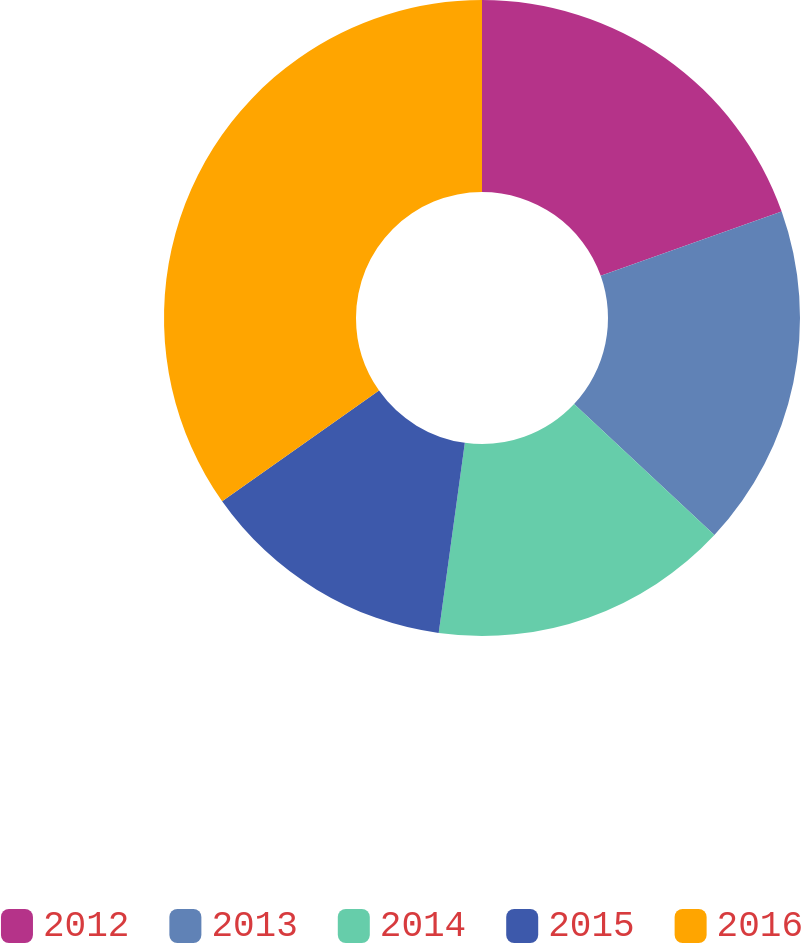<chart> <loc_0><loc_0><loc_500><loc_500><pie_chart><fcel>2012<fcel>2013<fcel>2014<fcel>2015<fcel>2016<nl><fcel>19.57%<fcel>17.39%<fcel>15.22%<fcel>13.05%<fcel>34.78%<nl></chart> 